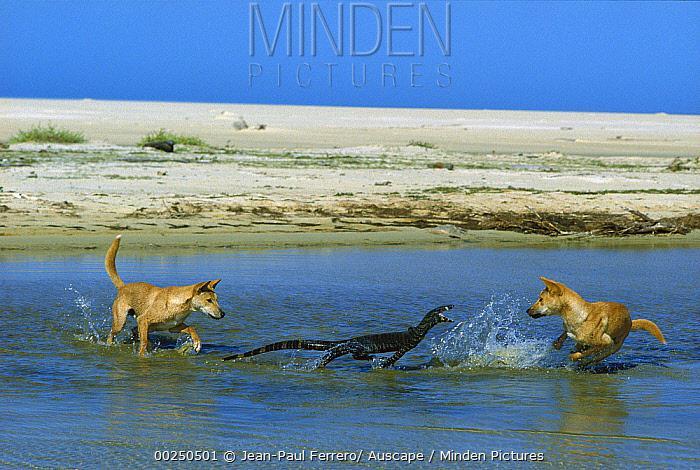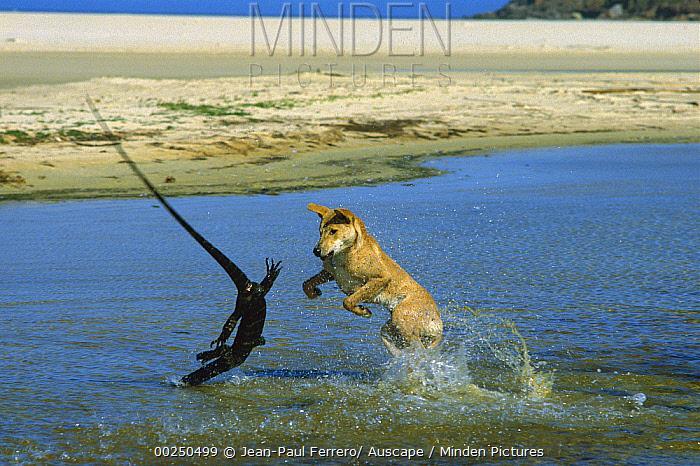The first image is the image on the left, the second image is the image on the right. Analyze the images presented: Is the assertion "In each image there are a pair of dogs on a shore attacking a large lizard." valid? Answer yes or no. No. 